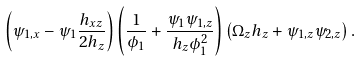Convert formula to latex. <formula><loc_0><loc_0><loc_500><loc_500>\left ( \psi _ { 1 , x } - \psi _ { 1 } \frac { h _ { x z } } { 2 h _ { z } } \right ) \left ( \frac { 1 } { \phi _ { 1 } } + \frac { \psi _ { 1 } \psi _ { 1 , z } } { h _ { z } \phi _ { 1 } ^ { 2 } } \right ) \left ( \Omega _ { z } h _ { z } + \psi _ { 1 , z } \psi _ { 2 , z } \right ) .</formula> 